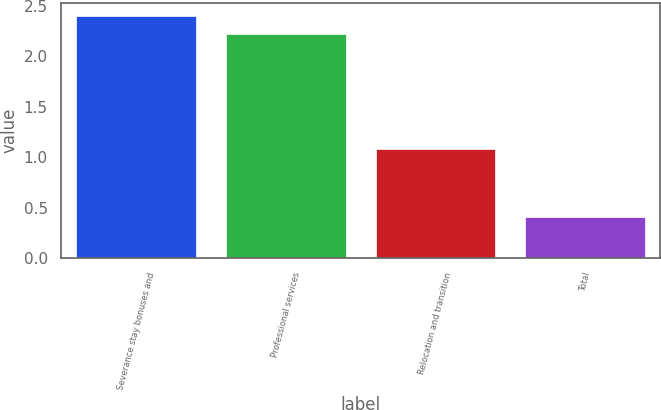Convert chart. <chart><loc_0><loc_0><loc_500><loc_500><bar_chart><fcel>Severance stay bonuses and<fcel>Professional services<fcel>Relocation and transition<fcel>Total<nl><fcel>2.4<fcel>2.22<fcel>1.08<fcel>0.41<nl></chart> 